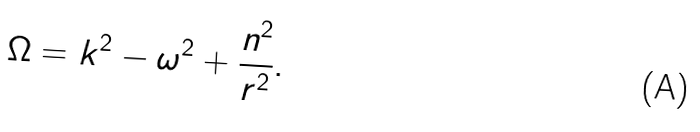Convert formula to latex. <formula><loc_0><loc_0><loc_500><loc_500>\Omega = k ^ { 2 } - \omega ^ { 2 } + \frac { n ^ { 2 } } { r ^ { 2 } } .</formula> 